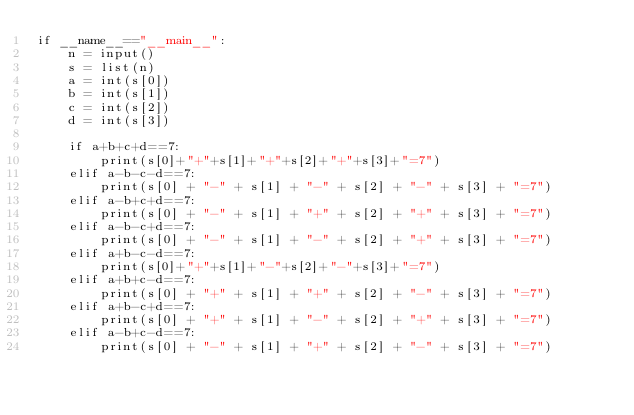Convert code to text. <code><loc_0><loc_0><loc_500><loc_500><_Python_>if __name__=="__main__":
    n = input()
    s = list(n)
    a = int(s[0])
    b = int(s[1])
    c = int(s[2])
    d = int(s[3])

    if a+b+c+d==7:
        print(s[0]+"+"+s[1]+"+"+s[2]+"+"+s[3]+"=7")
    elif a-b-c-d==7:
        print(s[0] + "-" + s[1] + "-" + s[2] + "-" + s[3] + "=7")
    elif a-b+c+d==7:
        print(s[0] + "-" + s[1] + "+" + s[2] + "+" + s[3] + "=7")
    elif a-b-c+d==7:
        print(s[0] + "-" + s[1] + "-" + s[2] + "+" + s[3] + "=7")
    elif a+b-c-d==7:
        print(s[0]+"+"+s[1]+"-"+s[2]+"-"+s[3]+"=7")
    elif a+b+c-d==7:
        print(s[0] + "+" + s[1] + "+" + s[2] + "-" + s[3] + "=7")
    elif a+b-c+d==7:
        print(s[0] + "+" + s[1] + "-" + s[2] + "+" + s[3] + "=7")
    elif a-b+c-d==7:
        print(s[0] + "-" + s[1] + "+" + s[2] + "-" + s[3] + "=7")

</code> 